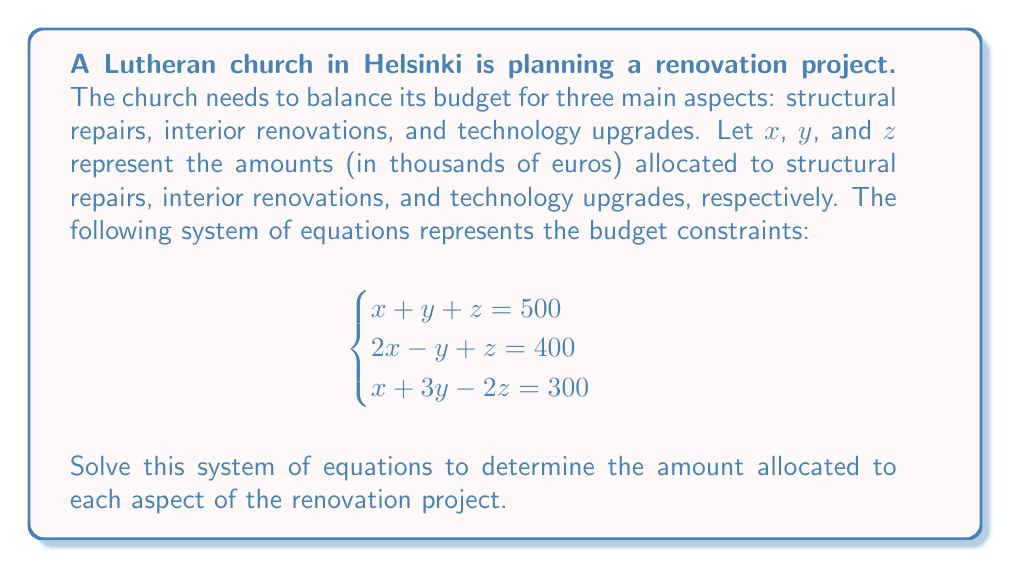Could you help me with this problem? Let's solve this system of equations using the elimination method:

1) From the first equation: $x + y + z = 500$ ... (1)

2) From the second equation: $2x - y + z = 400$ ... (2)

3) From the third equation: $x + 3y - 2z = 300$ ... (3)

4) Subtract equation (1) from equation (2):
   $(2x - y + z) - (x + y + z) = 400 - 500$
   $x - 2y = -100$ ... (4)

5) Add equation (1) to equation (3):
   $(x + y + z) + (x + 3y - 2z) = 500 + 300$
   $2x + 4y - z = 800$ ... (5)

6) Multiply equation (4) by 2 and add to equation (5):
   $2(x - 2y) + (2x + 4y - z) = 2(-100) + 800$
   $4x - z = 600$ ... (6)

7) From equation (1): $z = 500 - x - y$ ... (7)
   Substitute this into equation (6):
   $4x - (500 - x - y) = 600$
   $5x + y = 1100$ ... (8)

8) Substitute equation (4) into equation (8):
   $5x + (x - 100) = 1100$
   $6x = 1200$
   $x = 200$

9) Substitute $x = 200$ into equation (4):
   $200 - 2y = -100$
   $2y = 300$
   $y = 150$

10) Substitute $x = 200$ and $y = 150$ into equation (1):
    $200 + 150 + z = 500$
    $z = 150$

Therefore, the solution is $x = 200$, $y = 150$, and $z = 150$.
Answer: Structural repairs: €200,000; Interior renovations: €150,000; Technology upgrades: €150,000 